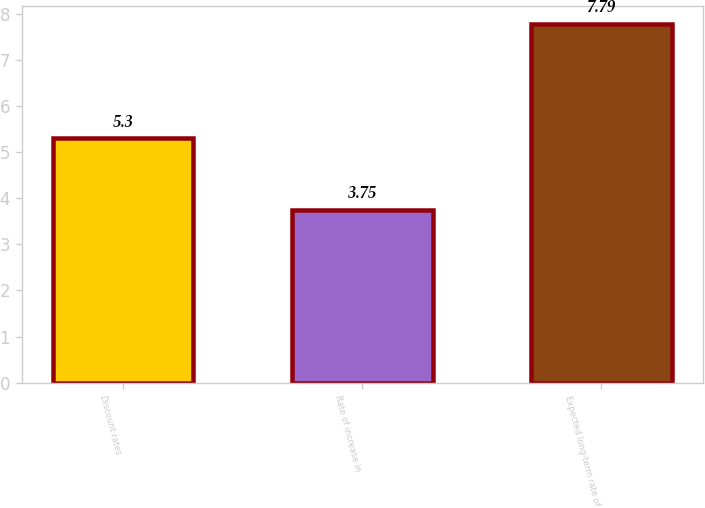<chart> <loc_0><loc_0><loc_500><loc_500><bar_chart><fcel>Discount rates<fcel>Rate of increase in<fcel>Expected long-term rate of<nl><fcel>5.3<fcel>3.75<fcel>7.79<nl></chart> 